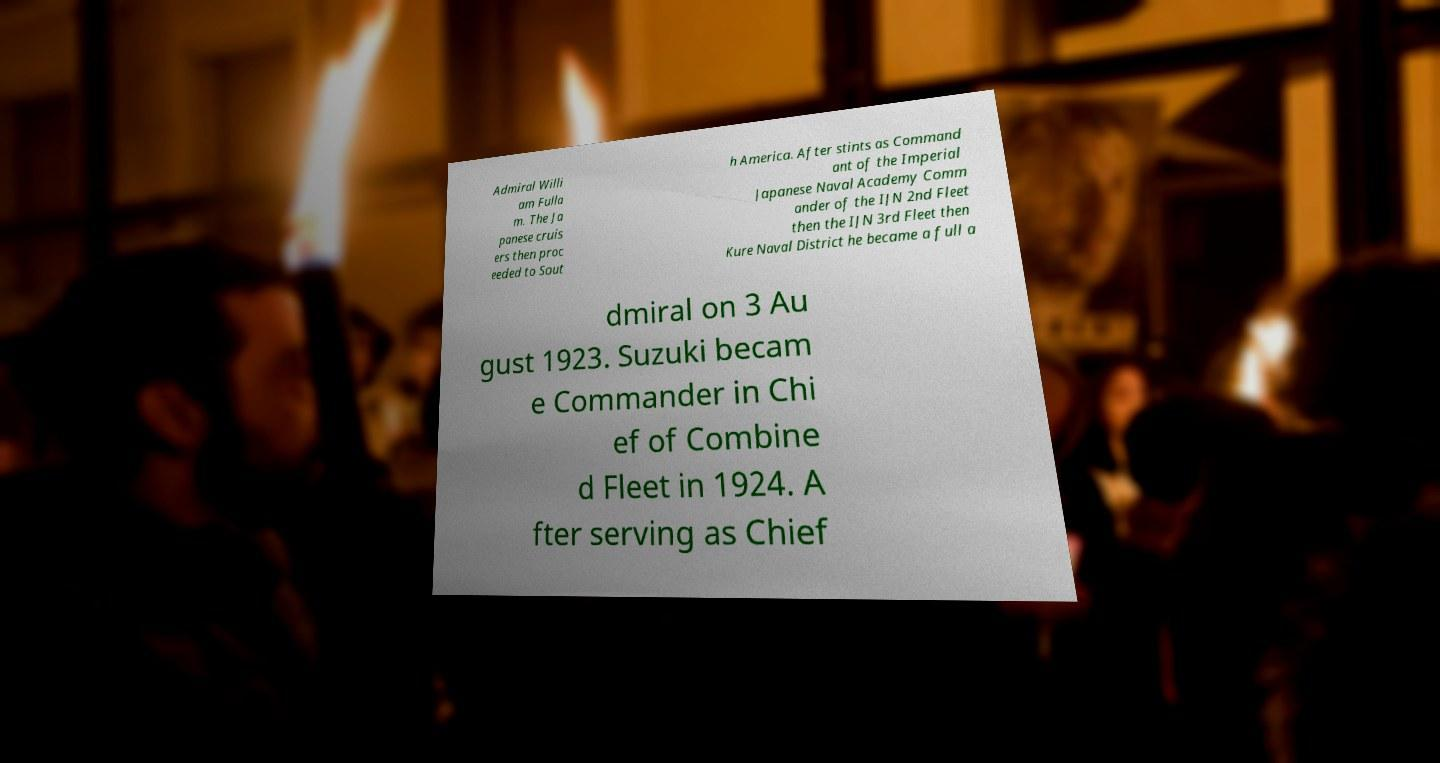I need the written content from this picture converted into text. Can you do that? Admiral Willi am Fulla m. The Ja panese cruis ers then proc eeded to Sout h America. After stints as Command ant of the Imperial Japanese Naval Academy Comm ander of the IJN 2nd Fleet then the IJN 3rd Fleet then Kure Naval District he became a full a dmiral on 3 Au gust 1923. Suzuki becam e Commander in Chi ef of Combine d Fleet in 1924. A fter serving as Chief 